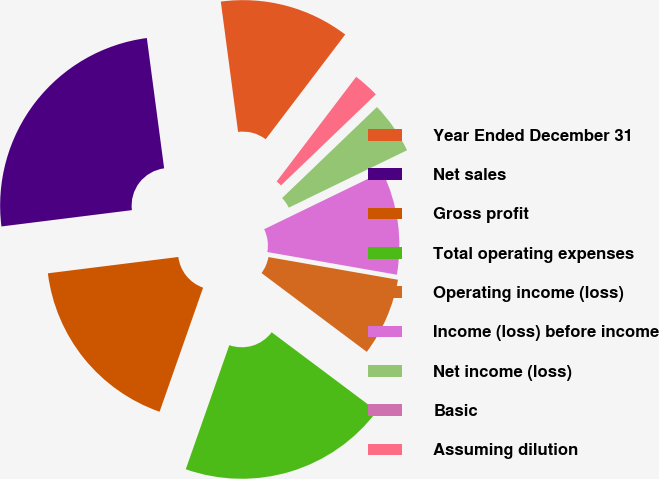Convert chart. <chart><loc_0><loc_0><loc_500><loc_500><pie_chart><fcel>Year Ended December 31<fcel>Net sales<fcel>Gross profit<fcel>Total operating expenses<fcel>Operating income (loss)<fcel>Income (loss) before income<fcel>Net income (loss)<fcel>Basic<fcel>Assuming dilution<nl><fcel>12.44%<fcel>24.88%<fcel>17.65%<fcel>20.14%<fcel>7.47%<fcel>9.95%<fcel>4.98%<fcel>0.0%<fcel>2.49%<nl></chart> 